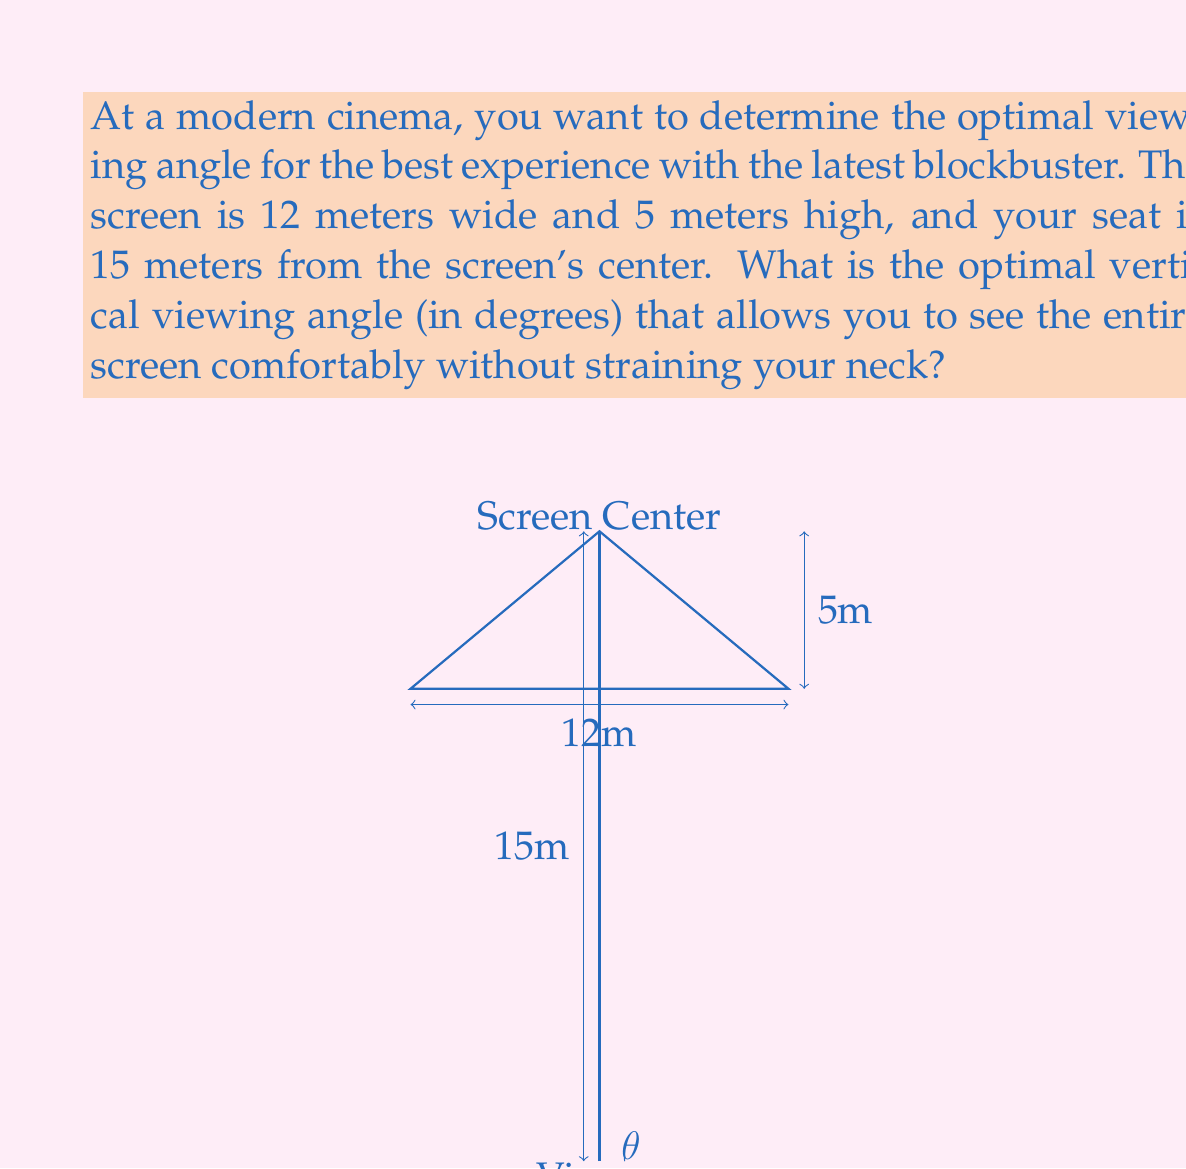Provide a solution to this math problem. Let's approach this step-by-step:

1) First, we need to understand what the optimal viewing angle means. It's the angle between the horizontal line of sight and the line from the viewer to the top of the screen.

2) We can use the tangent function to find this angle. The tangent of the angle is the ratio of the opposite side (half the screen height) to the adjacent side (distance to the screen).

3) The screen is 5 meters high, so half of it is 2.5 meters above the center.

4) We can set up the tangent equation:

   $$\tan(\theta) = \frac{\text{opposite}}{\text{adjacent}} = \frac{2.5}{15}$$

5) To solve for θ, we need to use the inverse tangent (arctan or $\tan^{-1}$):

   $$\theta = \tan^{-1}\left(\frac{2.5}{15}\right)$$

6) Using a calculator or computer:

   $$\theta \approx 9.462322208\text{ degrees}$$

7) Rounding to two decimal places:

   $$\theta \approx 9.46\text{ degrees}$$

This angle represents the optimal vertical viewing angle from the center of the screen to the top edge, allowing for a comfortable viewing experience without neck strain.
Answer: $9.46^\circ$ 